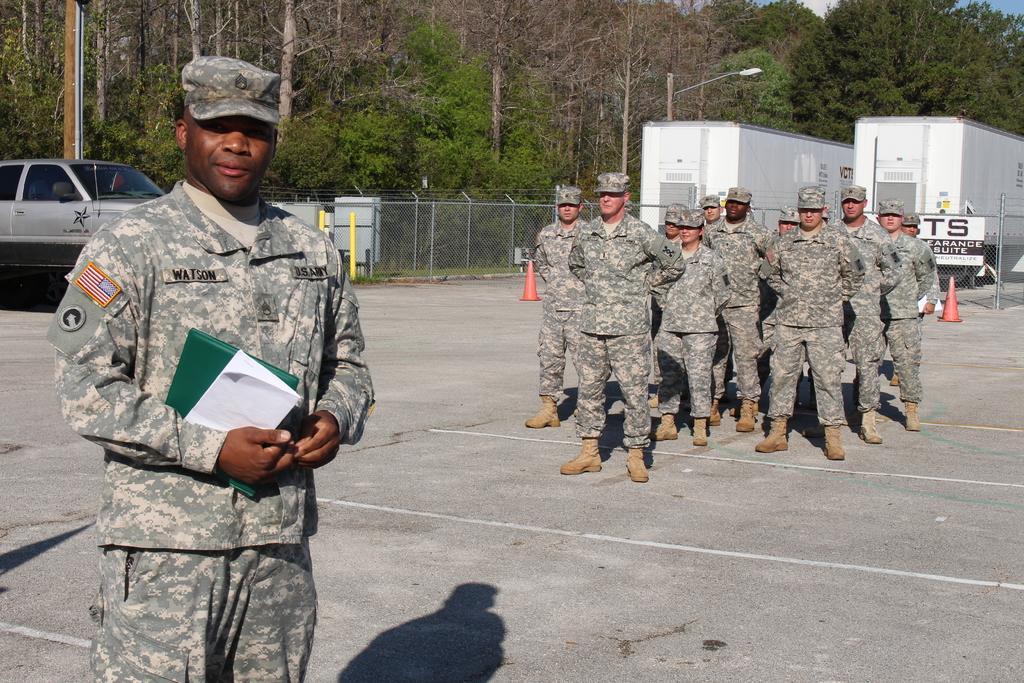Describe this image in one or two sentences. In this picture we can see some people are standing, a man in the front is holding a file and a paper, on the left side there is a car, we can see fencing and traffic cones in the middle, they are looking like containers on the right side, in the background we can see trees and a light, there is the sky at the right top of the picture. 